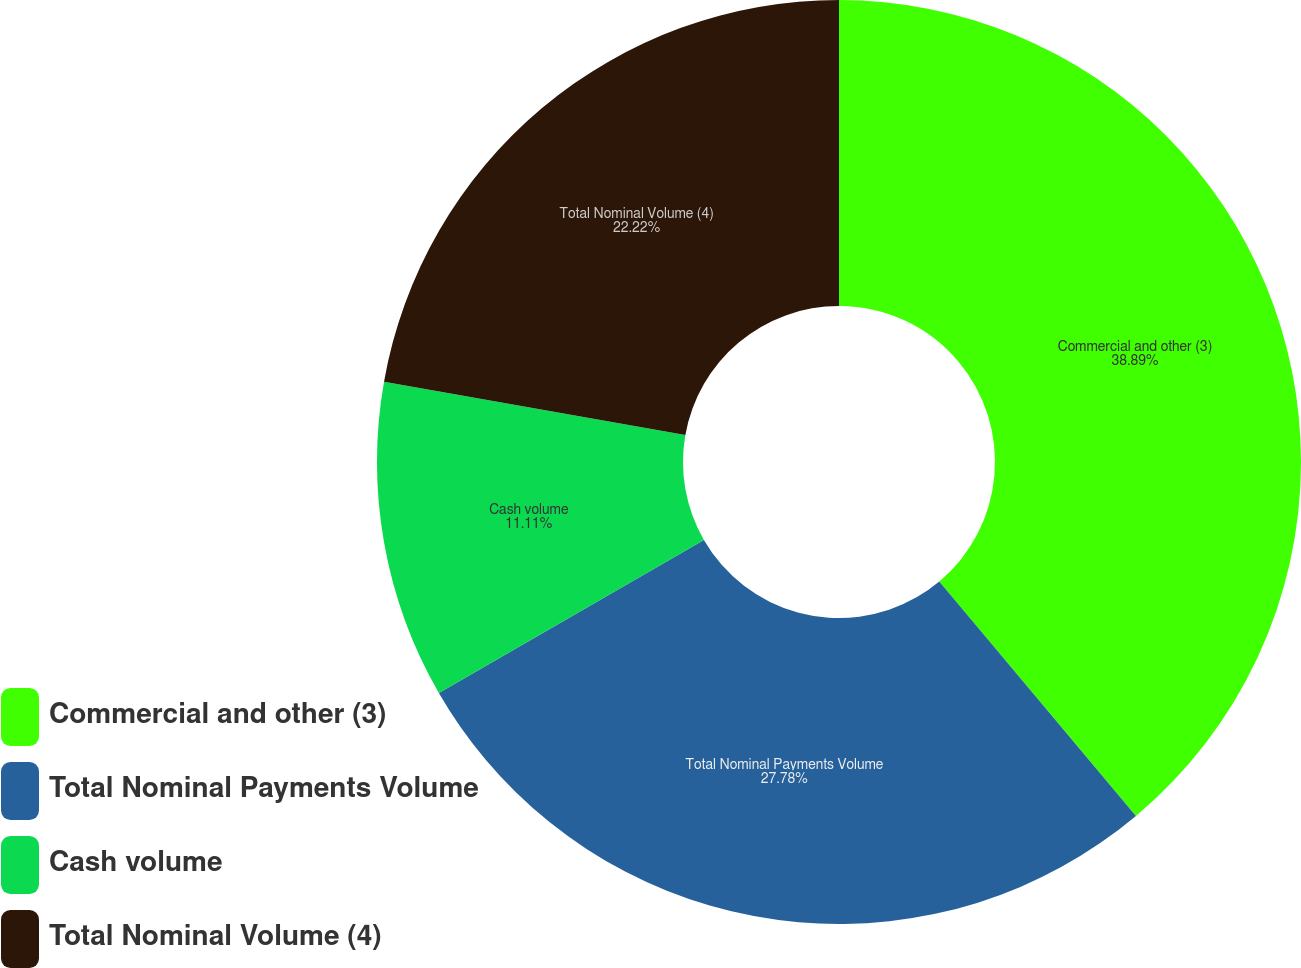Convert chart to OTSL. <chart><loc_0><loc_0><loc_500><loc_500><pie_chart><fcel>Commercial and other (3)<fcel>Total Nominal Payments Volume<fcel>Cash volume<fcel>Total Nominal Volume (4)<nl><fcel>38.89%<fcel>27.78%<fcel>11.11%<fcel>22.22%<nl></chart> 